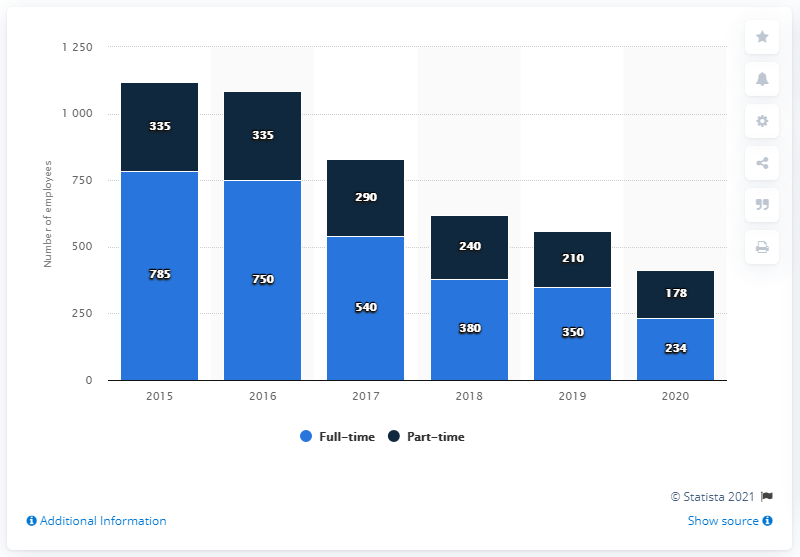Mention a couple of crucial points in this snapshot. In 2019, Emmis Communications had a total of 210 full-time employees. In 2020, Emmis Communications employed a total of 178 part-time employees. As of February 2020, Emmis Communications employed a total of 234 full-time employees. Emmis Communications employed 350 full-time employees in the previous year. 